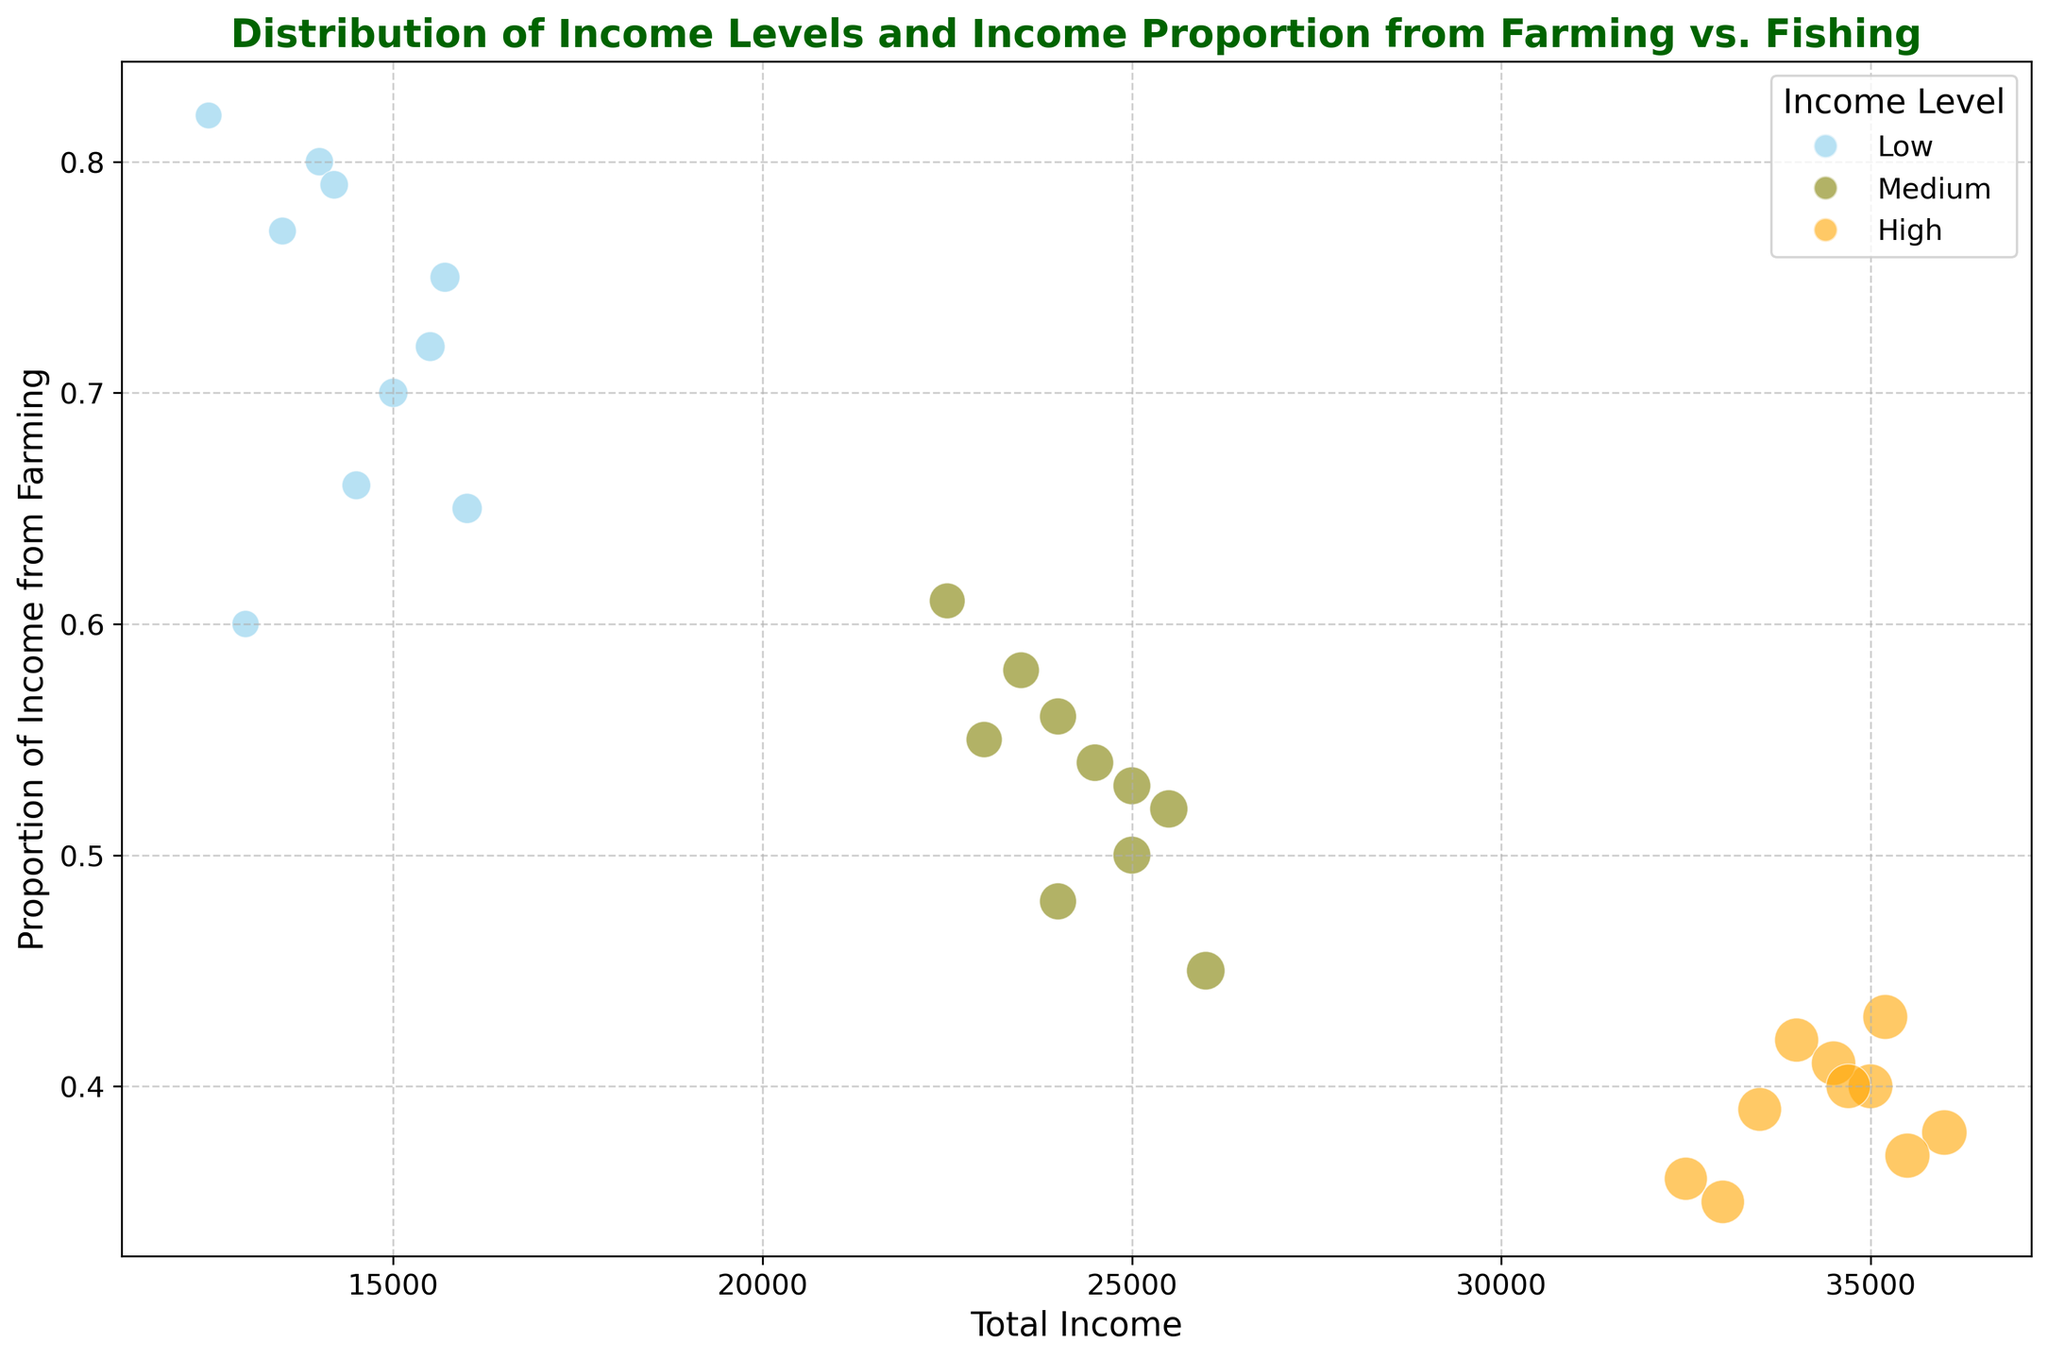What proportion of income levels have the highest total income from farming? The "Low" income level has bubbles that reach total incomes up to around $16,000 with a high proportion of income from farming, reaching up to around 0.82. This is higher compared to proportions in the "Medium" income level which is generally below 0.61 and "High" income level, which is below 0.43.
Answer: Low Which income level has the lowest proportion of income from farming? Looking at the x-axis and y-axis, we can see that "High" income level bubbles mostly fall below 0.43 in the proportion of income from farming. This is lower compared to "Medium" and "Low" income levels.
Answer: High How do the proportion of incomes from farming for Low and Medium income levels compare? For "Low" income levels, proportions range between 0.6 and 0.82. For "Medium" income levels, proportions range between 0.45 and 0.61. Therefore, "Low" has a higher range of income proportion from farming compared to "Medium".
Answer: Low has higher On average, which income level seems to have larger total incomes? The "High" income level clearly has larger bubbles (representing total income) positioned between $32,500 and $36,000. This is significantly higher than both the "Low" and "Medium" income levels, which have total incomes below $26,000.
Answer: High What is the general trend in the proportion of income from farming as total income increases? As total income increases across "Low", "Medium", and "High" income levels, the proportion of income from farming generally decreases. "Low" has the highest proportions and total income, followed by "Medium" with moderate proportions and incomes, and "High" with the lowest proportions.
Answer: Decreases Is there any overlap in the total income values between the income levels? By visually inspecting the x-axis, we see there is no overlap. "Low" stays below $16,000, "Medium" stays between $22,500 and $26,000, and "High" remains above $32,500.
Answer: No overlap 